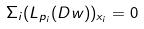<formula> <loc_0><loc_0><loc_500><loc_500>\Sigma _ { i } ( L _ { p _ { i } } ( D w ) ) _ { x _ { i } } = 0</formula> 